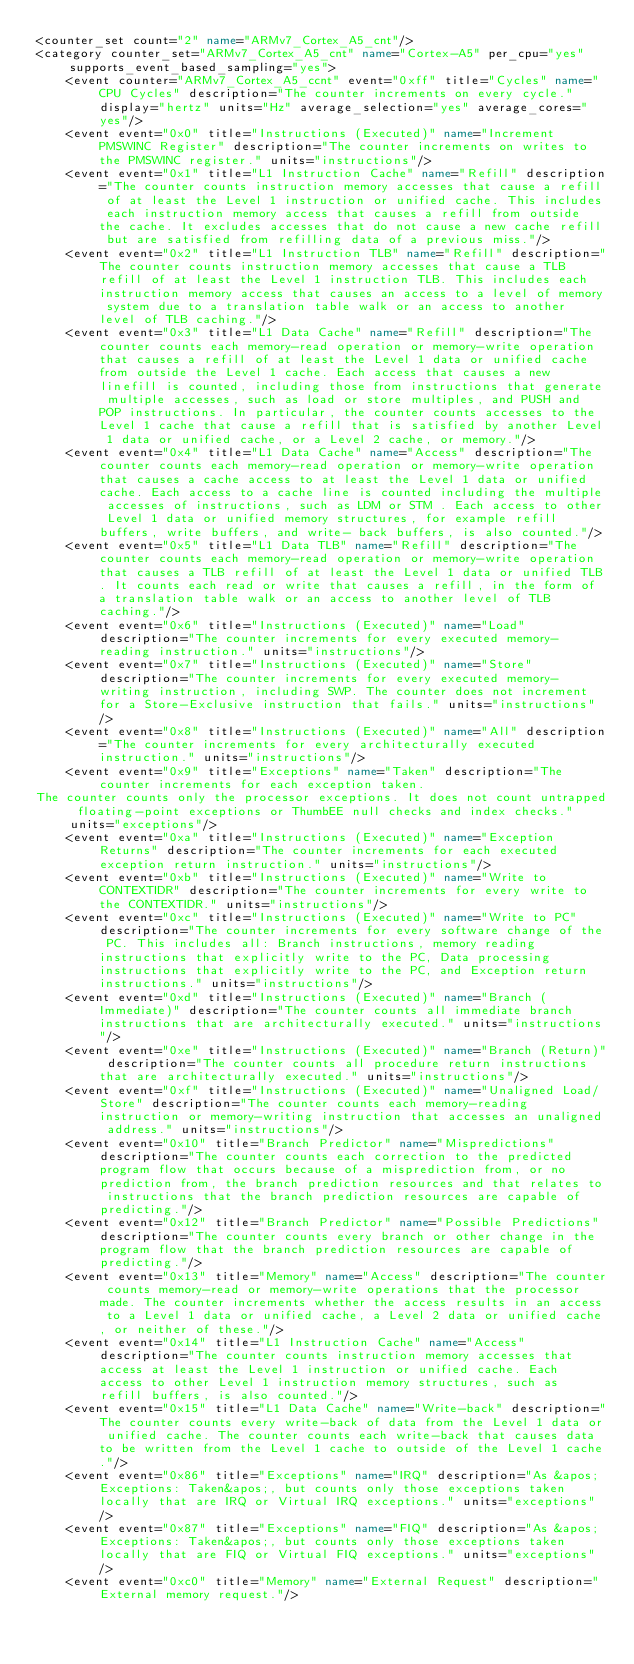<code> <loc_0><loc_0><loc_500><loc_500><_XML_><counter_set count="2" name="ARMv7_Cortex_A5_cnt"/>
<category counter_set="ARMv7_Cortex_A5_cnt" name="Cortex-A5" per_cpu="yes" supports_event_based_sampling="yes">
    <event counter="ARMv7_Cortex_A5_ccnt" event="0xff" title="Cycles" name="CPU Cycles" description="The counter increments on every cycle." display="hertz" units="Hz" average_selection="yes" average_cores="yes"/>
    <event event="0x0" title="Instructions (Executed)" name="Increment PMSWINC Register" description="The counter increments on writes to the PMSWINC register." units="instructions"/>
    <event event="0x1" title="L1 Instruction Cache" name="Refill" description="The counter counts instruction memory accesses that cause a refill of at least the Level 1 instruction or unified cache. This includes each instruction memory access that causes a refill from outside the cache. It excludes accesses that do not cause a new cache refill but are satisfied from refilling data of a previous miss."/>
    <event event="0x2" title="L1 Instruction TLB" name="Refill" description="The counter counts instruction memory accesses that cause a TLB refill of at least the Level 1 instruction TLB. This includes each instruction memory access that causes an access to a level of memory system due to a translation table walk or an access to another level of TLB caching."/>
    <event event="0x3" title="L1 Data Cache" name="Refill" description="The counter counts each memory-read operation or memory-write operation that causes a refill of at least the Level 1 data or unified cache from outside the Level 1 cache. Each access that causes a new linefill is counted, including those from instructions that generate multiple accesses, such as load or store multiples, and PUSH and POP instructions. In particular, the counter counts accesses to the Level 1 cache that cause a refill that is satisfied by another Level 1 data or unified cache, or a Level 2 cache, or memory."/>
    <event event="0x4" title="L1 Data Cache" name="Access" description="The counter counts each memory-read operation or memory-write operation that causes a cache access to at least the Level 1 data or unified cache. Each access to a cache line is counted including the multiple accesses of instructions, such as LDM or STM . Each access to other Level 1 data or unified memory structures, for example refill buffers, write buffers, and write- back buffers, is also counted."/>
    <event event="0x5" title="L1 Data TLB" name="Refill" description="The counter counts each memory-read operation or memory-write operation that causes a TLB refill of at least the Level 1 data or unified TLB. It counts each read or write that causes a refill, in the form of a translation table walk or an access to another level of TLB caching."/>
    <event event="0x6" title="Instructions (Executed)" name="Load" description="The counter increments for every executed memory-reading instruction." units="instructions"/>
    <event event="0x7" title="Instructions (Executed)" name="Store" description="The counter increments for every executed memory-writing instruction, including SWP. The counter does not increment for a Store-Exclusive instruction that fails." units="instructions"/>
    <event event="0x8" title="Instructions (Executed)" name="All" description="The counter increments for every architecturally executed instruction." units="instructions"/>
    <event event="0x9" title="Exceptions" name="Taken" description="The counter increments for each exception taken.
The counter counts only the processor exceptions. It does not count untrapped floating-point exceptions or ThumbEE null checks and index checks." units="exceptions"/>
    <event event="0xa" title="Instructions (Executed)" name="Exception Returns" description="The counter increments for each executed exception return instruction." units="instructions"/>
    <event event="0xb" title="Instructions (Executed)" name="Write to CONTEXTIDR" description="The counter increments for every write to the CONTEXTIDR." units="instructions"/>
    <event event="0xc" title="Instructions (Executed)" name="Write to PC" description="The counter increments for every software change of the PC. This includes all: Branch instructions, memory reading instructions that explicitly write to the PC, Data processing instructions that explicitly write to the PC, and Exception return instructions." units="instructions"/>
    <event event="0xd" title="Instructions (Executed)" name="Branch (Immediate)" description="The counter counts all immediate branch instructions that are architecturally executed." units="instructions"/>
    <event event="0xe" title="Instructions (Executed)" name="Branch (Return)" description="The counter counts all procedure return instructions that are architecturally executed." units="instructions"/>
    <event event="0xf" title="Instructions (Executed)" name="Unaligned Load/Store" description="The counter counts each memory-reading instruction or memory-writing instruction that accesses an unaligned address." units="instructions"/>
    <event event="0x10" title="Branch Predictor" name="Mispredictions" description="The counter counts each correction to the predicted program flow that occurs because of a misprediction from, or no prediction from, the branch prediction resources and that relates to instructions that the branch prediction resources are capable of predicting."/>
    <event event="0x12" title="Branch Predictor" name="Possible Predictions" description="The counter counts every branch or other change in the program flow that the branch prediction resources are capable of predicting."/>
    <event event="0x13" title="Memory" name="Access" description="The counter counts memory-read or memory-write operations that the processor made. The counter increments whether the access results in an access to a Level 1 data or unified cache, a Level 2 data or unified cache, or neither of these."/>
    <event event="0x14" title="L1 Instruction Cache" name="Access" description="The counter counts instruction memory accesses that access at least the Level 1 instruction or unified cache. Each access to other Level 1 instruction memory structures, such as refill buffers, is also counted."/>
    <event event="0x15" title="L1 Data Cache" name="Write-back" description="The counter counts every write-back of data from the Level 1 data or unified cache. The counter counts each write-back that causes data to be written from the Level 1 cache to outside of the Level 1 cache."/>
    <event event="0x86" title="Exceptions" name="IRQ" description="As &apos;Exceptions: Taken&apos;, but counts only those exceptions taken locally that are IRQ or Virtual IRQ exceptions." units="exceptions"/>
    <event event="0x87" title="Exceptions" name="FIQ" description="As &apos;Exceptions: Taken&apos;, but counts only those exceptions taken locally that are FIQ or Virtual FIQ exceptions." units="exceptions"/>
    <event event="0xc0" title="Memory" name="External Request" description="External memory request."/></code> 